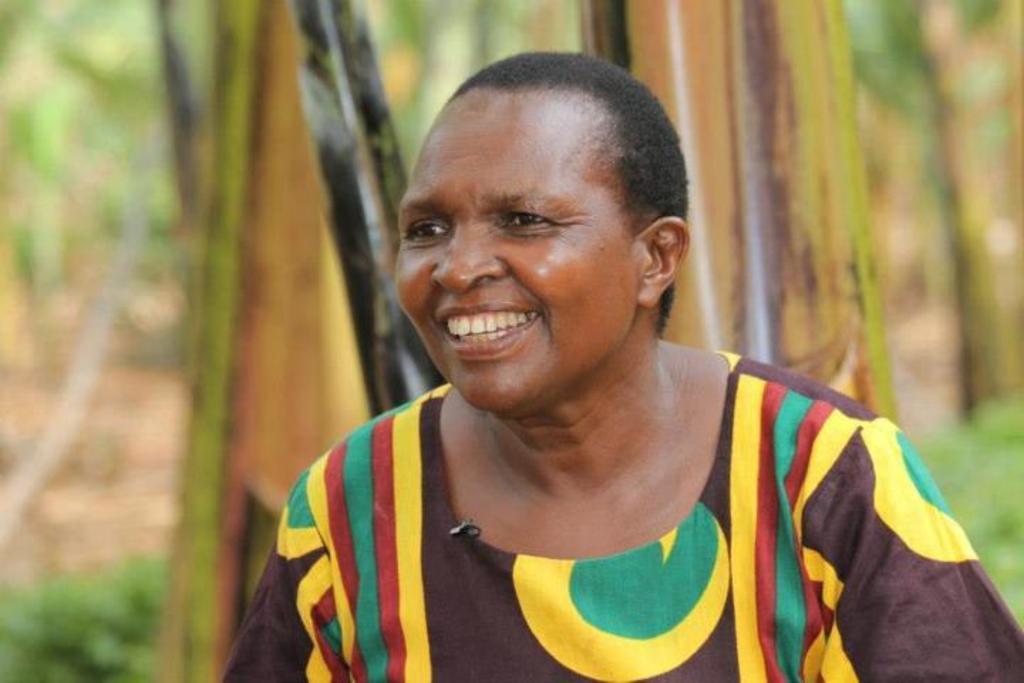Please provide a concise description of this image. This image consists of a woman laughing. It looks like the image is clicked outside. In the background, there are trees. At the bottom, there is green grass. 